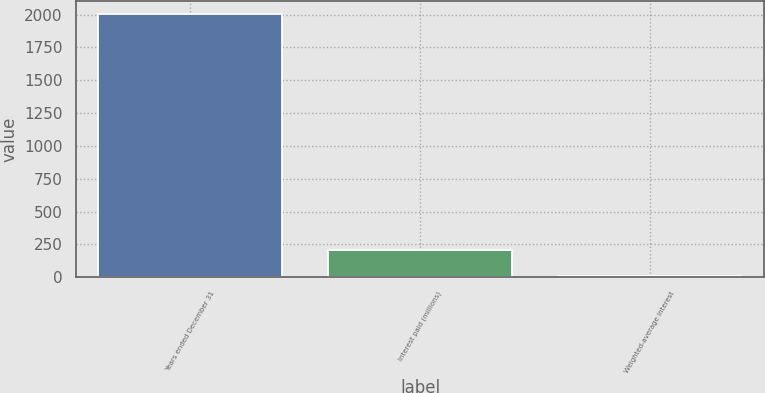Convert chart. <chart><loc_0><loc_0><loc_500><loc_500><bar_chart><fcel>Years ended December 31<fcel>Interest paid (millions)<fcel>Weighted-average interest<nl><fcel>2007<fcel>205.29<fcel>5.1<nl></chart> 